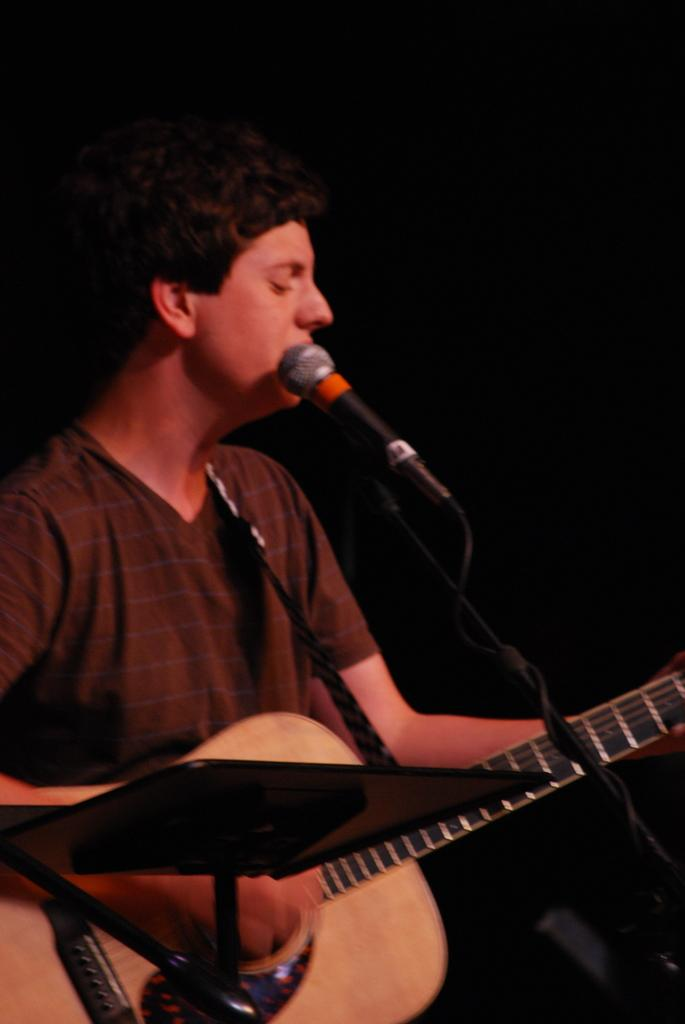What is the man in the image doing? The man is standing, playing a guitar, singing, and using a microphone. What instrument is the man playing in the image? The man is playing a guitar in the image. How is the man's voice being amplified in the image? The man is using a microphone to amplify his voice in the image. What type of snake can be seen slithering around the man's feet in the image? There is no snake present in the image; the man is playing a guitar, singing, and using a microphone. 